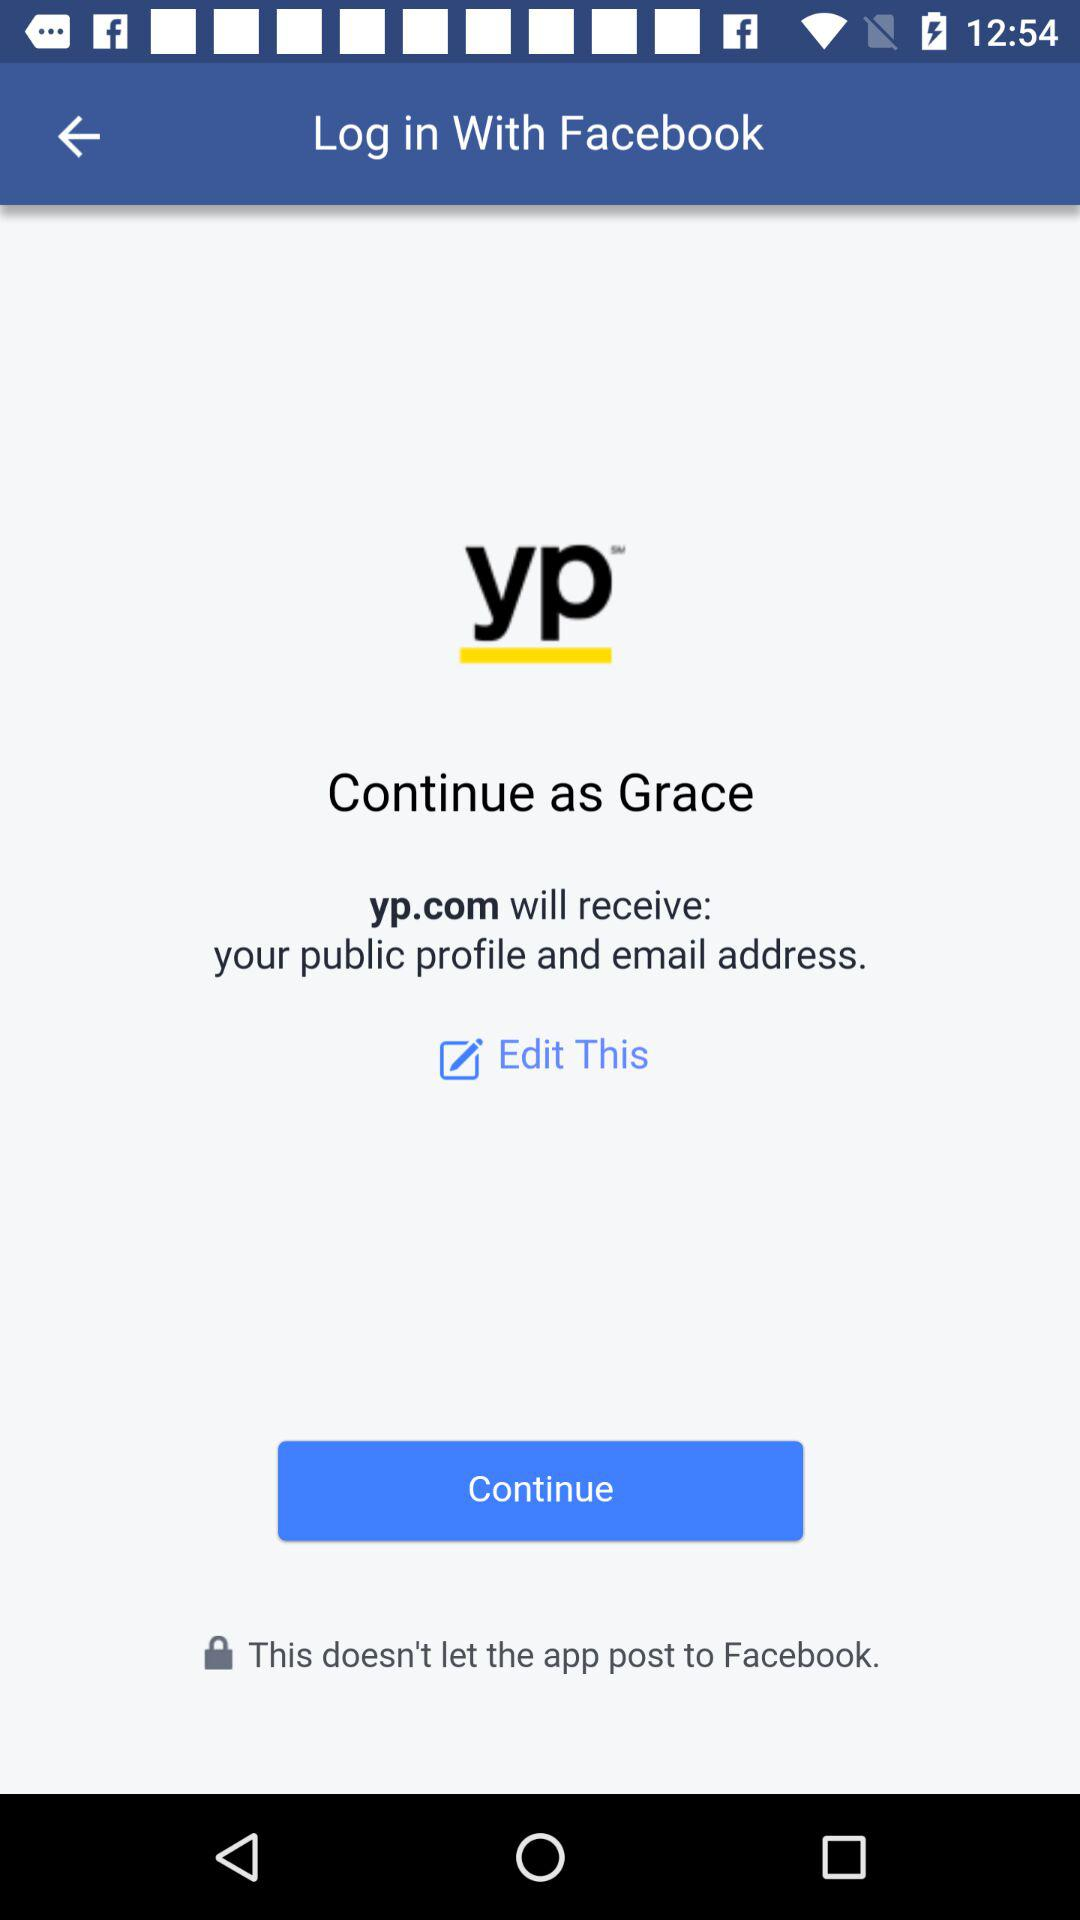What is the name of the user? The name of the user is Grace. 